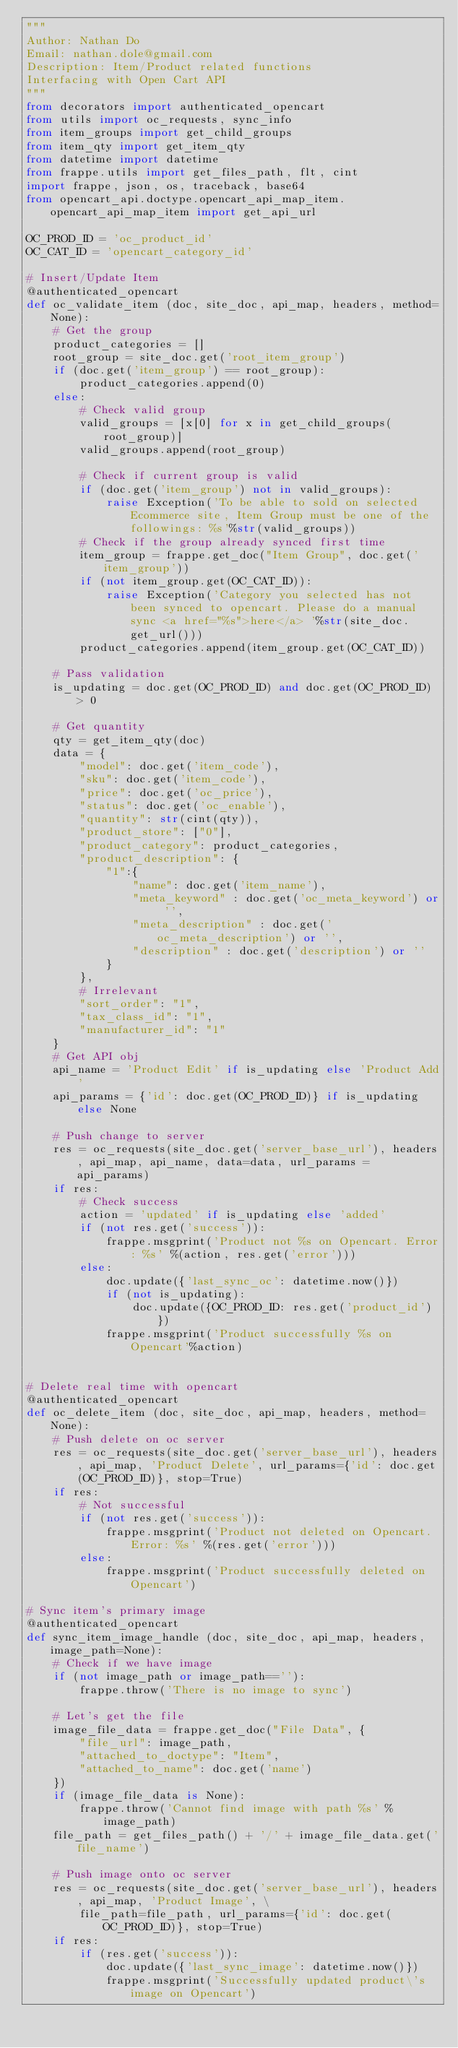<code> <loc_0><loc_0><loc_500><loc_500><_Python_>"""
Author: Nathan Do
Email: nathan.dole@gmail.com
Description: Item/Product related functions
Interfacing with Open Cart API
"""
from decorators import authenticated_opencart
from utils import oc_requests, sync_info
from item_groups import get_child_groups
from item_qty import get_item_qty
from datetime import datetime
from frappe.utils import get_files_path, flt, cint
import frappe, json, os, traceback, base64
from opencart_api.doctype.opencart_api_map_item.opencart_api_map_item import get_api_url

OC_PROD_ID = 'oc_product_id'
OC_CAT_ID = 'opencart_category_id'

# Insert/Update Item
@authenticated_opencart
def oc_validate_item (doc, site_doc, api_map, headers, method=None):
    # Get the group
    product_categories = []
    root_group = site_doc.get('root_item_group')
    if (doc.get('item_group') == root_group):
        product_categories.append(0)
    else:
        # Check valid group
        valid_groups = [x[0] for x in get_child_groups(root_group)]
        valid_groups.append(root_group)

        # Check if current group is valid
        if (doc.get('item_group') not in valid_groups):
            raise Exception('To be able to sold on selected Ecommerce site, Item Group must be one of the followings: %s'%str(valid_groups))
        # Check if the group already synced first time
        item_group = frappe.get_doc("Item Group", doc.get('item_group'))
        if (not item_group.get(OC_CAT_ID)):
            raise Exception('Category you selected has not been synced to opencart. Please do a manual sync <a href="%s">here</a> '%str(site_doc.get_url()))
        product_categories.append(item_group.get(OC_CAT_ID))

    # Pass validation
    is_updating = doc.get(OC_PROD_ID) and doc.get(OC_PROD_ID) > 0

    # Get quantity
    qty = get_item_qty(doc)
    data = {
    	"model": doc.get('item_code'),
    	"sku": doc.get('item_code'),
    	"price": doc.get('oc_price'),
    	"status": doc.get('oc_enable'),
        "quantity": str(cint(qty)),
        "product_store": ["0"],
        "product_category": product_categories,
        "product_description": {
    		"1":{
    			"name": doc.get('item_name'),
    			"meta_keyword" : doc.get('oc_meta_keyword') or '',
                "meta_description" : doc.get('oc_meta_description') or '',
    			"description" : doc.get('description') or ''
    		}
    	},
        # Irrelevant
        "sort_order": "1",
    	"tax_class_id": "1",
    	"manufacturer_id": "1"
    }
    # Get API obj
    api_name = 'Product Edit' if is_updating else 'Product Add'
    api_params = {'id': doc.get(OC_PROD_ID)} if is_updating else None

    # Push change to server
    res = oc_requests(site_doc.get('server_base_url'), headers, api_map, api_name, data=data, url_params = api_params)
    if res:
        # Check success
        action = 'updated' if is_updating else 'added'
        if (not res.get('success')):
            frappe.msgprint('Product not %s on Opencart. Error: %s' %(action, res.get('error')))
        else:
            doc.update({'last_sync_oc': datetime.now()})
            if (not is_updating):
                doc.update({OC_PROD_ID: res.get('product_id')})
            frappe.msgprint('Product successfully %s on Opencart'%action)


# Delete real time with opencart
@authenticated_opencart
def oc_delete_item (doc, site_doc, api_map, headers, method=None):
    # Push delete on oc server
    res = oc_requests(site_doc.get('server_base_url'), headers, api_map, 'Product Delete', url_params={'id': doc.get(OC_PROD_ID)}, stop=True)
    if res:
        # Not successful
        if (not res.get('success')):
            frappe.msgprint('Product not deleted on Opencart. Error: %s' %(res.get('error')))
        else:
            frappe.msgprint('Product successfully deleted on Opencart')

# Sync item's primary image
@authenticated_opencart
def sync_item_image_handle (doc, site_doc, api_map, headers, image_path=None):
    # Check if we have image
    if (not image_path or image_path==''):
        frappe.throw('There is no image to sync')

    # Let's get the file
    image_file_data = frappe.get_doc("File Data", {
		"file_url": image_path,
		"attached_to_doctype": "Item",
		"attached_to_name": doc.get('name')
	})
    if (image_file_data is None):
        frappe.throw('Cannot find image with path %s' %image_path)
    file_path = get_files_path() + '/' + image_file_data.get('file_name')

    # Push image onto oc server
    res = oc_requests(site_doc.get('server_base_url'), headers, api_map, 'Product Image', \
        file_path=file_path, url_params={'id': doc.get(OC_PROD_ID)}, stop=True)
    if res:
        if (res.get('success')):
            doc.update({'last_sync_image': datetime.now()})
            frappe.msgprint('Successfully updated product\'s image on Opencart')</code> 